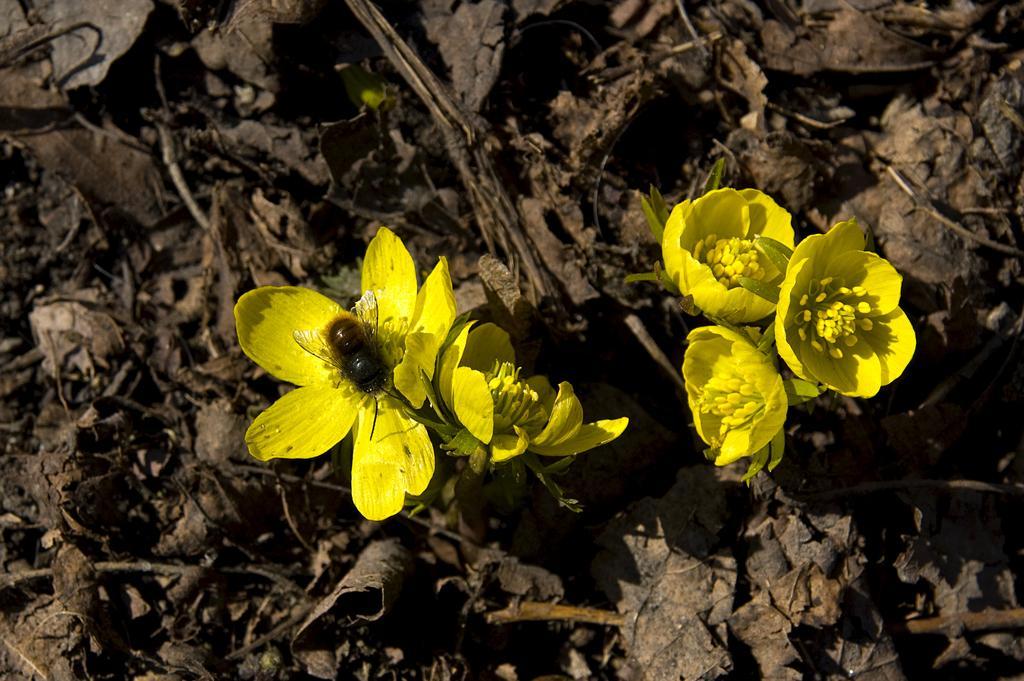Could you give a brief overview of what you see in this image? In this image we can see yellow color flowers and an insect on a flower and in the background there are dried leaves. 